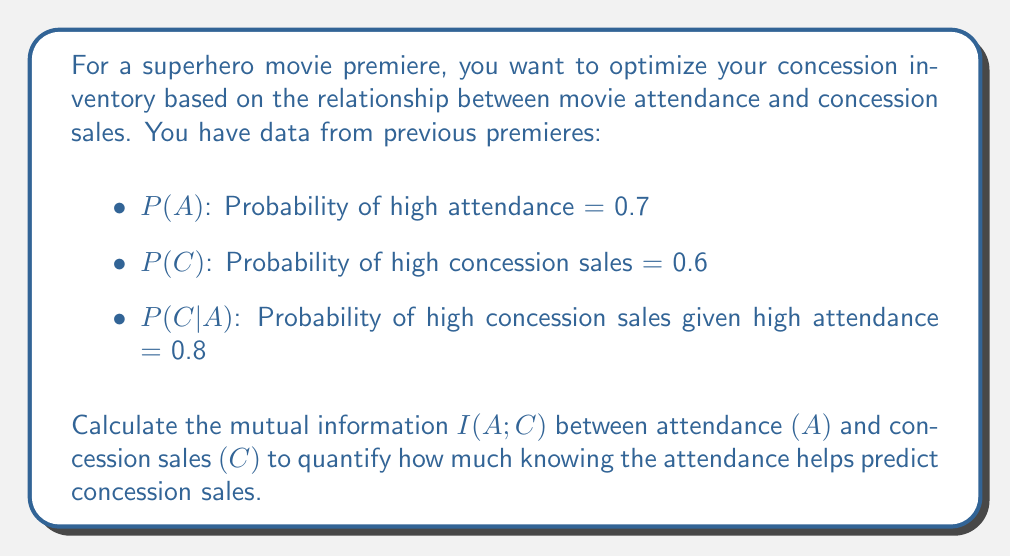Can you answer this question? To calculate the mutual information I(A;C), we'll follow these steps:

1) First, we need to find P(A,C) using the given P(C|A):
   $$P(A,C) = P(C|A) \cdot P(A) = 0.8 \cdot 0.7 = 0.56$$

2) Now we can calculate P(C|not A):
   $$P(C) = P(C|A) \cdot P(A) + P(C|not A) \cdot P(not A)$$
   $$0.6 = 0.8 \cdot 0.7 + P(C|not A) \cdot 0.3$$
   $$P(C|not A) = \frac{0.6 - 0.56}{0.3} = \frac{0.04}{0.3} \approx 0.133$$

3) The mutual information is defined as:
   $$I(A;C) = \sum_{a \in A} \sum_{c \in C} P(a,c) \log_2 \frac{P(a,c)}{P(a)P(c)}$$

4) We need to calculate this for all combinations of A and C:
   
   For A=1 (high attendance) and C=1 (high concession sales):
   $$P(A=1,C=1) \log_2 \frac{P(A=1,C=1)}{P(A=1)P(C=1)} = 0.56 \log_2 \frac{0.56}{0.7 \cdot 0.6} \approx 0.1271$$

   For A=1 and C=0:
   $$P(A=1,C=0) \log_2 \frac{P(A=1,C=0)}{P(A=1)P(C=0)} = 0.14 \log_2 \frac{0.14}{0.7 \cdot 0.4} \approx 0.0118$$

   For A=0 and C=1:
   $$P(A=0,C=1) \log_2 \frac{P(A=0,C=1)}{P(A=0)P(C=1)} = 0.04 \log_2 \frac{0.04}{0.3 \cdot 0.6} \approx 0.0118$$

   For A=0 and C=0:
   $$P(A=0,C=0) \log_2 \frac{P(A=0,C=0)}{P(A=0)P(C=0)} = 0.26 \log_2 \frac{0.26}{0.3 \cdot 0.4} \approx 0.1271$$

5) Sum all these values to get I(A;C):
   $$I(A;C) = 0.1271 + 0.0118 + 0.0118 + 0.1271 = 0.2778 \text{ bits}$$
Answer: The mutual information I(A;C) between attendance and concession sales is approximately 0.2778 bits. 